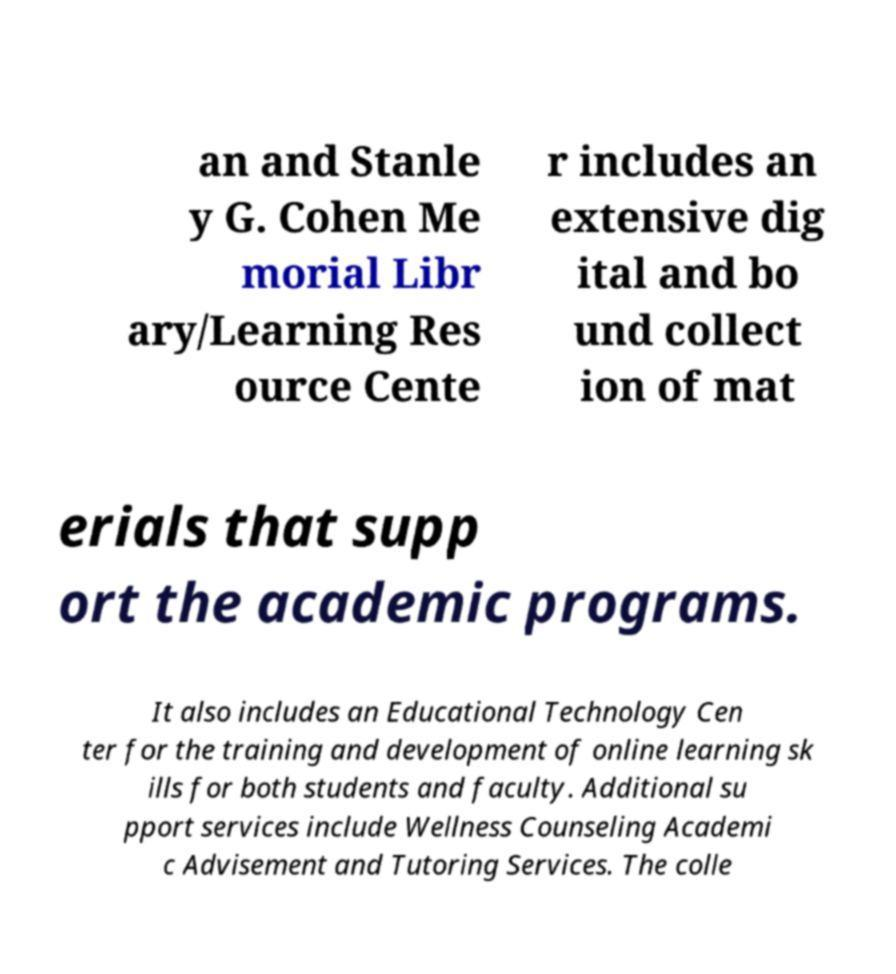Please identify and transcribe the text found in this image. an and Stanle y G. Cohen Me morial Libr ary/Learning Res ource Cente r includes an extensive dig ital and bo und collect ion of mat erials that supp ort the academic programs. It also includes an Educational Technology Cen ter for the training and development of online learning sk ills for both students and faculty. Additional su pport services include Wellness Counseling Academi c Advisement and Tutoring Services. The colle 